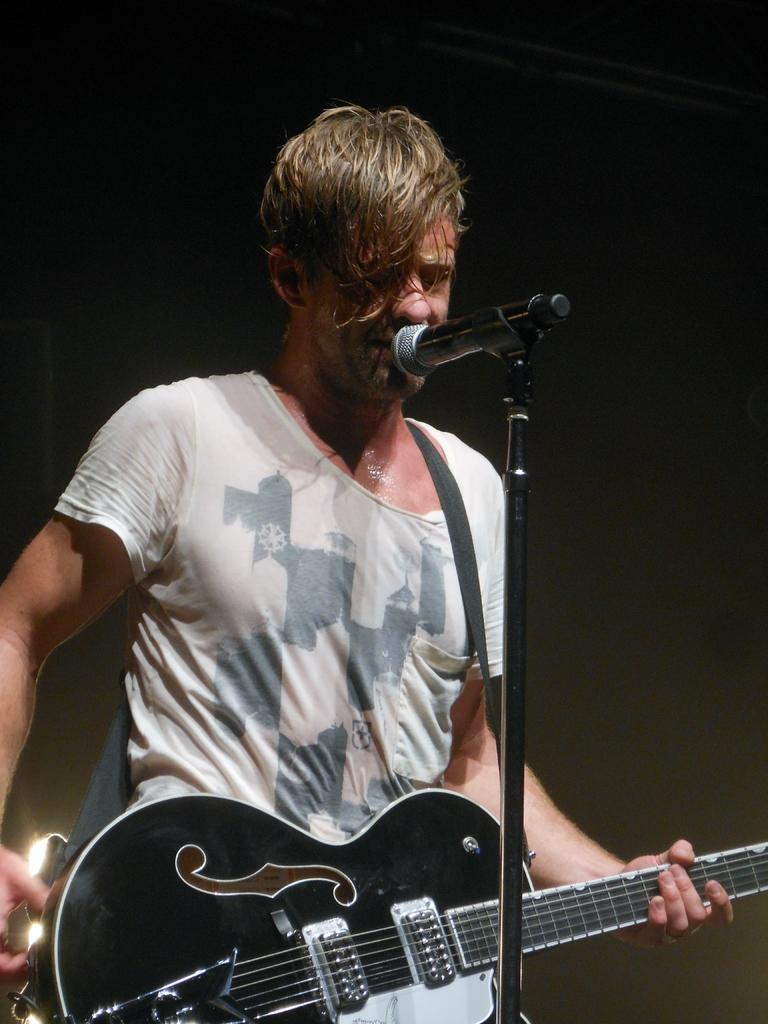What is the person in the image doing? The person is playing a guitar. How is the person positioned in the image? The person is standing. What is the person wearing in the image? The person is wearing a white t-shirt. What other object can be seen in the image related to the person's activity? There is a microphone in the image. What type of coal is being used to fuel the person's guitar in the image? There is no coal present in the image, and the guitar is not being fueled by coal. 